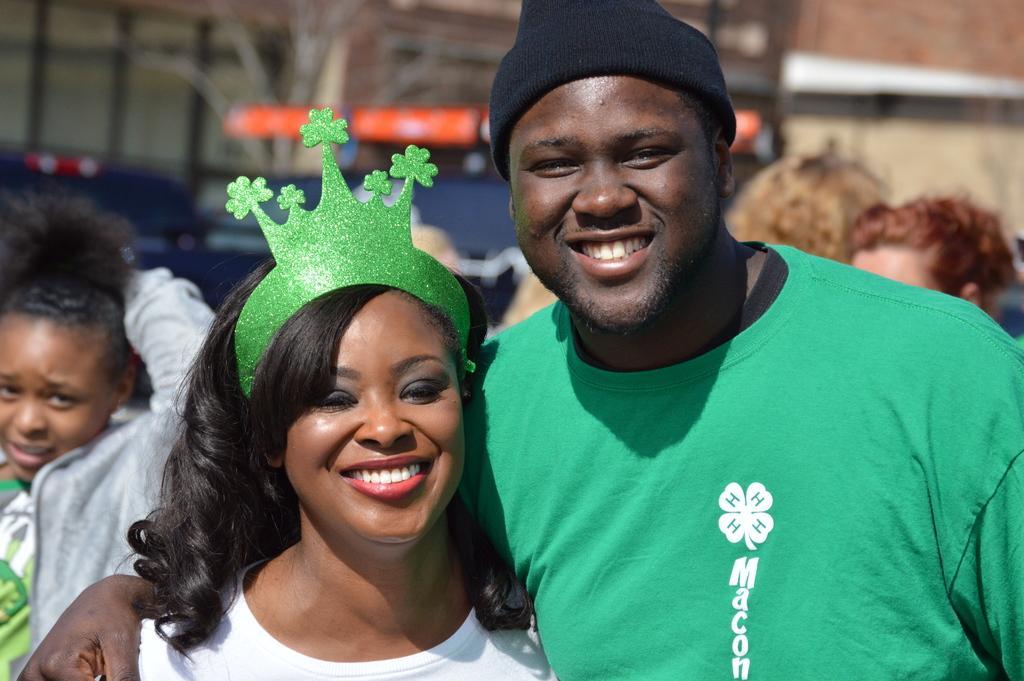Could you give a brief overview of what you see in this image? In this image I can see the group of people standing. In front the person is wearing green color shirt and the person at left is wearing white color shirt and I can see the blurred background. 